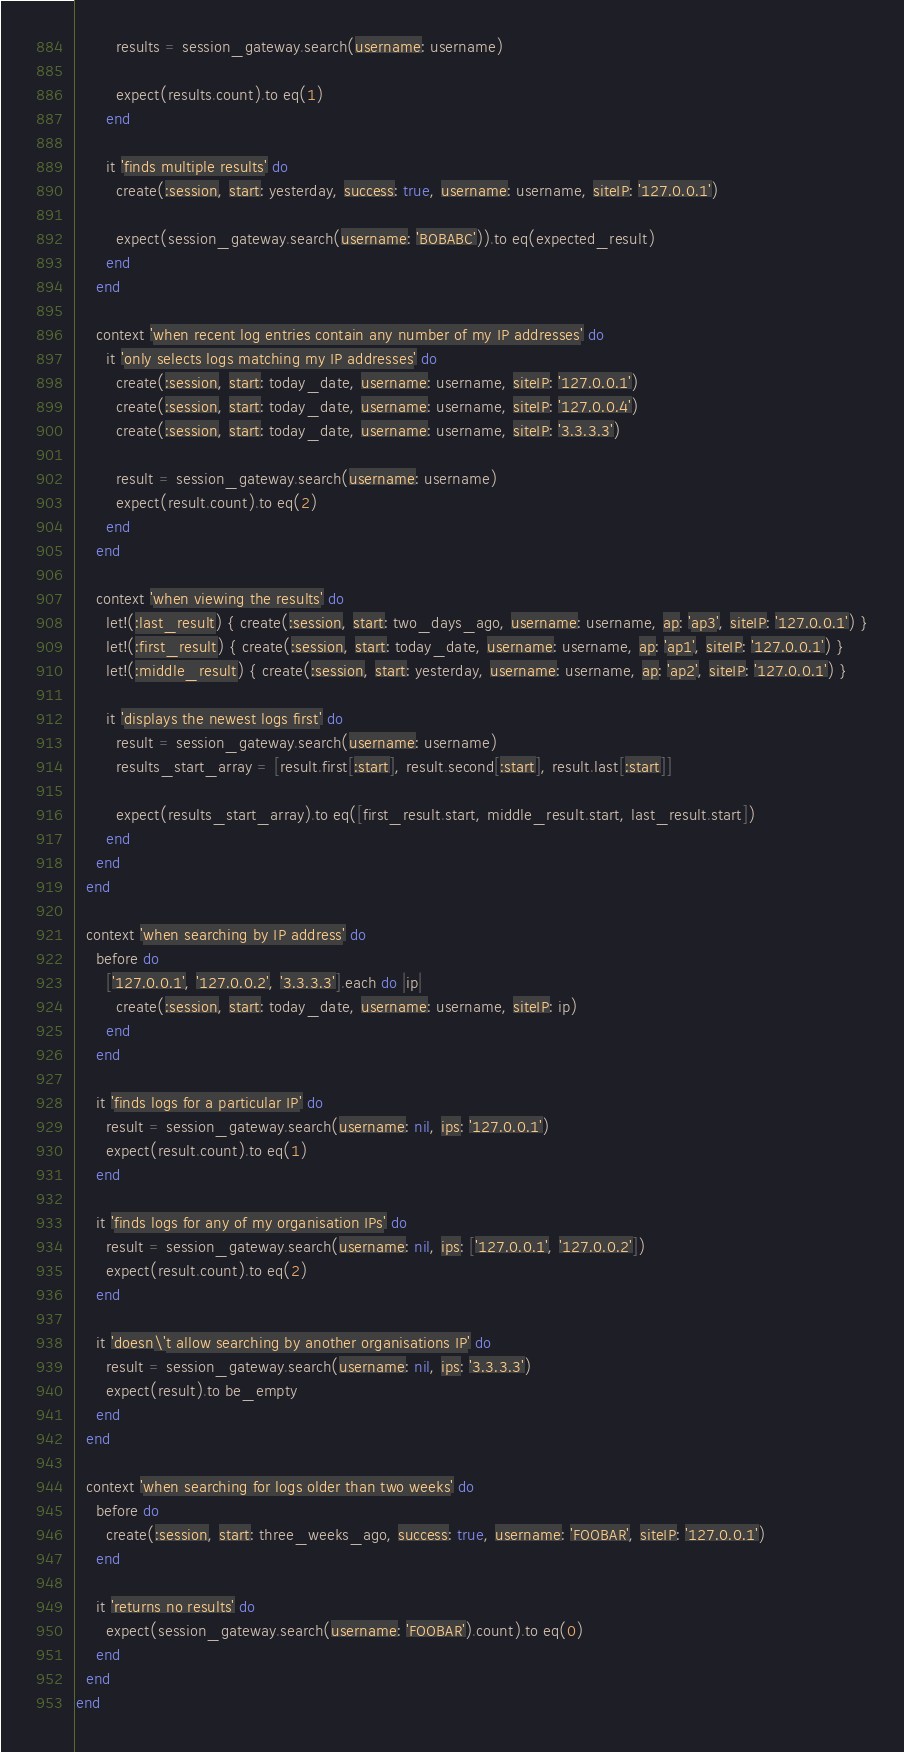<code> <loc_0><loc_0><loc_500><loc_500><_Ruby_>        results = session_gateway.search(username: username)

        expect(results.count).to eq(1)
      end

      it 'finds multiple results' do
        create(:session, start: yesterday, success: true, username: username, siteIP: '127.0.0.1')

        expect(session_gateway.search(username: 'BOBABC')).to eq(expected_result)
      end
    end

    context 'when recent log entries contain any number of my IP addresses' do
      it 'only selects logs matching my IP addresses' do
        create(:session, start: today_date, username: username, siteIP: '127.0.0.1')
        create(:session, start: today_date, username: username, siteIP: '127.0.0.4')
        create(:session, start: today_date, username: username, siteIP: '3.3.3.3')

        result = session_gateway.search(username: username)
        expect(result.count).to eq(2)
      end
    end

    context 'when viewing the results' do
      let!(:last_result) { create(:session, start: two_days_ago, username: username, ap: 'ap3', siteIP: '127.0.0.1') }
      let!(:first_result) { create(:session, start: today_date, username: username, ap: 'ap1', siteIP: '127.0.0.1') }
      let!(:middle_result) { create(:session, start: yesterday, username: username, ap: 'ap2', siteIP: '127.0.0.1') }

      it 'displays the newest logs first' do
        result = session_gateway.search(username: username)
        results_start_array = [result.first[:start], result.second[:start], result.last[:start]]

        expect(results_start_array).to eq([first_result.start, middle_result.start, last_result.start])
      end
    end
  end

  context 'when searching by IP address' do
    before do
      ['127.0.0.1', '127.0.0.2', '3.3.3.3'].each do |ip|
        create(:session, start: today_date, username: username, siteIP: ip)
      end
    end

    it 'finds logs for a particular IP' do
      result = session_gateway.search(username: nil, ips: '127.0.0.1')
      expect(result.count).to eq(1)
    end

    it 'finds logs for any of my organisation IPs' do
      result = session_gateway.search(username: nil, ips: ['127.0.0.1', '127.0.0.2'])
      expect(result.count).to eq(2)
    end

    it 'doesn\'t allow searching by another organisations IP' do
      result = session_gateway.search(username: nil, ips: '3.3.3.3')
      expect(result).to be_empty
    end
  end

  context 'when searching for logs older than two weeks' do
    before do
      create(:session, start: three_weeks_ago, success: true, username: 'FOOBAR', siteIP: '127.0.0.1')
    end

    it 'returns no results' do
      expect(session_gateway.search(username: 'FOOBAR').count).to eq(0)
    end
  end
end
</code> 